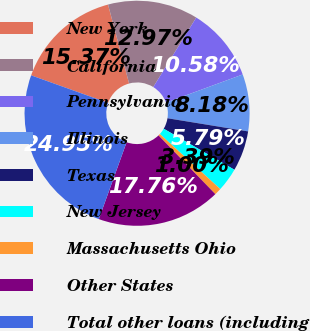Convert chart. <chart><loc_0><loc_0><loc_500><loc_500><pie_chart><fcel>New York<fcel>California<fcel>Pennsylvania<fcel>Illinois<fcel>Texas<fcel>New Jersey<fcel>Massachusetts Ohio<fcel>Other States<fcel>Total other loans (including<nl><fcel>15.37%<fcel>12.97%<fcel>10.58%<fcel>8.18%<fcel>5.79%<fcel>3.39%<fcel>1.0%<fcel>17.76%<fcel>24.95%<nl></chart> 